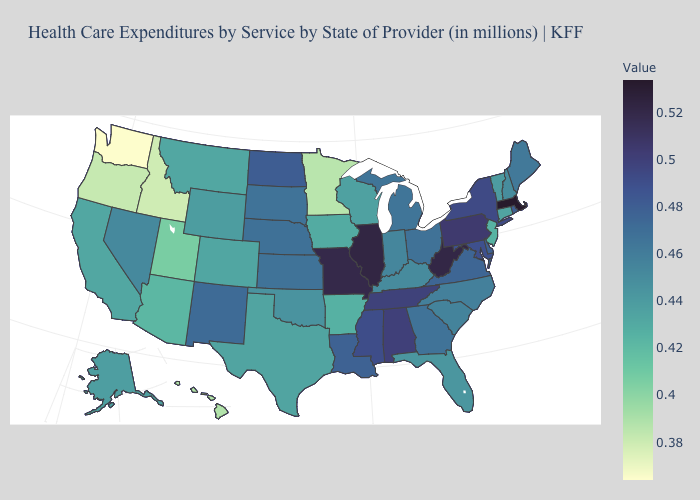Among the states that border Ohio , does Kentucky have the lowest value?
Be succinct. Yes. Does Washington have the lowest value in the West?
Concise answer only. Yes. Does Arkansas have a lower value than Washington?
Be succinct. No. Does Arkansas have a lower value than Kentucky?
Be succinct. Yes. Does Hawaii have a lower value than Washington?
Give a very brief answer. No. Among the states that border New Jersey , which have the highest value?
Give a very brief answer. Pennsylvania. Which states have the highest value in the USA?
Write a very short answer. Massachusetts. 